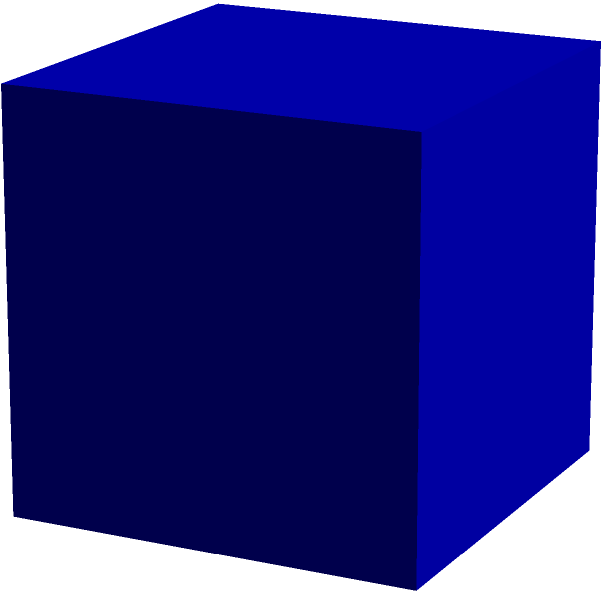As an author preparing to archive your collection, you've decided to use cube-shaped boxes for storing letters. If each box has an edge length of 12 inches, what is the total surface area of the box in square inches? Round your answer to the nearest whole number. To find the surface area of a cube, we need to follow these steps:

1. Recall the formula for the surface area of a cube:
   $SA = 6a^2$, where $a$ is the length of an edge.

2. We're given that the edge length is 12 inches.
   $a = 12$ inches

3. Substitute this value into the formula:
   $SA = 6(12^2)$

4. Calculate the square of 12:
   $SA = 6(144)$

5. Multiply:
   $SA = 864$ square inches

Since the question asks to round to the nearest whole number, and 864 is already a whole number, no rounding is necessary.
Answer: 864 square inches 